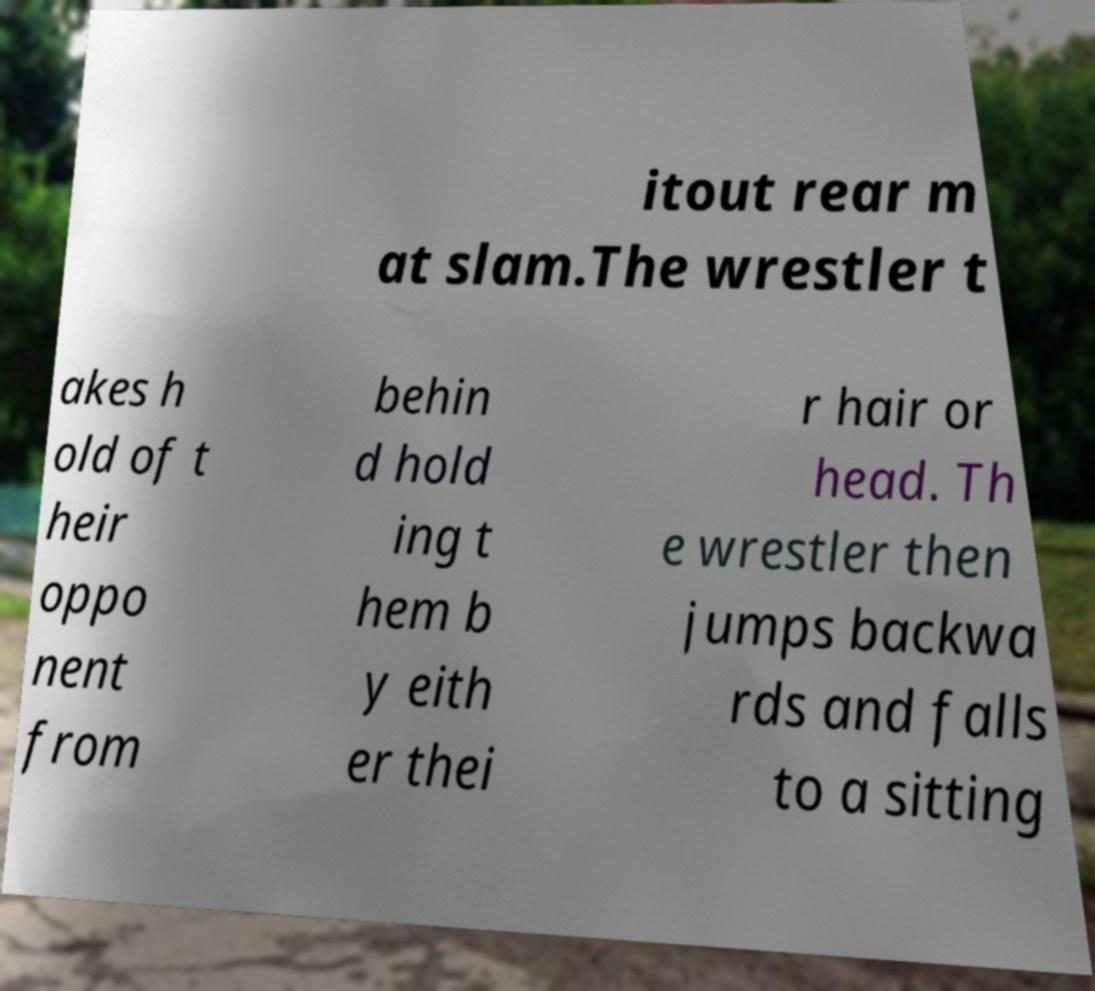Please read and relay the text visible in this image. What does it say? itout rear m at slam.The wrestler t akes h old of t heir oppo nent from behin d hold ing t hem b y eith er thei r hair or head. Th e wrestler then jumps backwa rds and falls to a sitting 